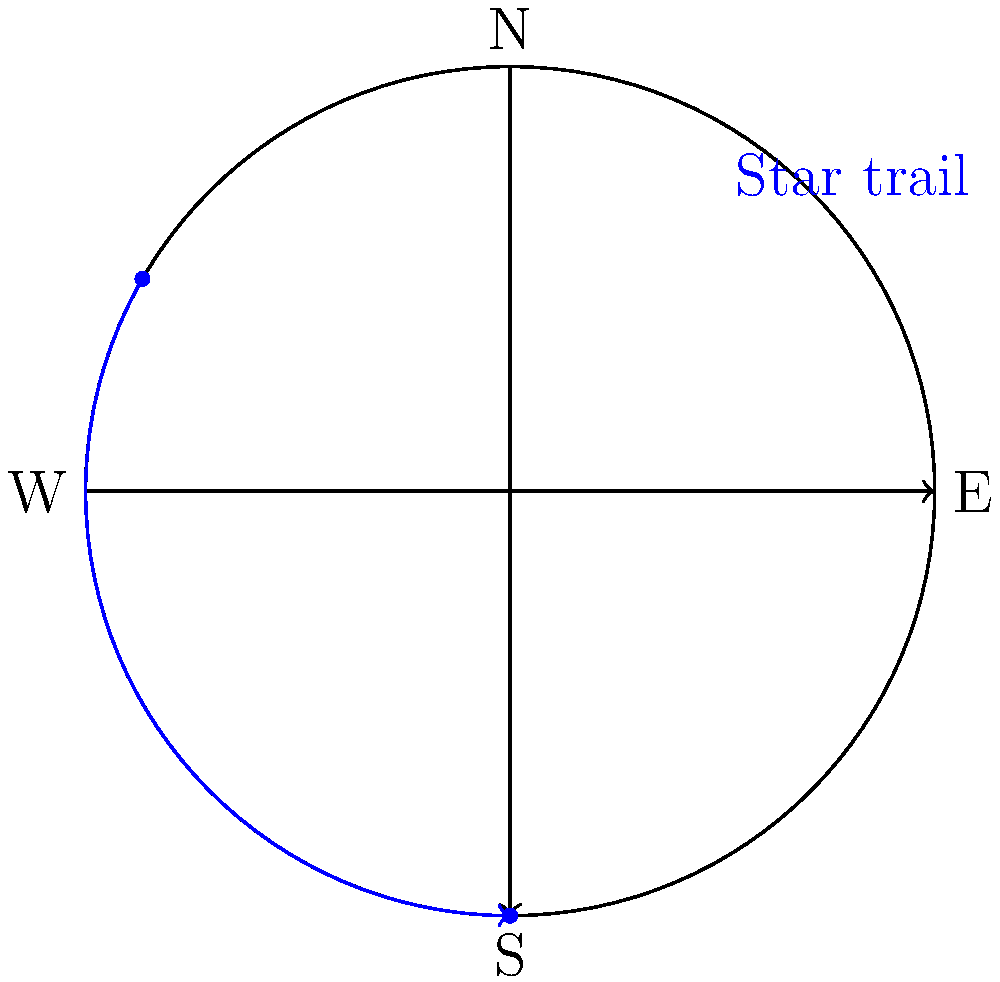In star trail photography, the apparent movement of stars creates circular patterns in long-exposure images. Based on the diagram, which shows a star's trail over a 4-hour period, how many degrees does the star appear to move per hour relative to an observer on Earth? To solve this problem, let's follow these steps:

1. Observe that the star's trail forms an arc on the circular path.
2. The full circular path represents a complete rotation of the Earth, which takes 24 hours.
3. In the diagram, the star's trail covers 1/3 of the full circle (120° out of 360°).
4. This 120° movement occurs over a 4-hour period.
5. To find the movement per hour, divide the total arc by the number of hours:
   $\frac{120°}{4 \text{ hours}} = 30°$ per hour

This rate of 30° per hour is consistent with Earth's rotation:
$\frac{360°}{24 \text{ hours}} = 15°$ per hour

The star appears to move at twice this rate (30° per hour) because it's traveling along a great circle of the celestial sphere, which is tilted relative to the observer's latitude.
Answer: 30° per hour 